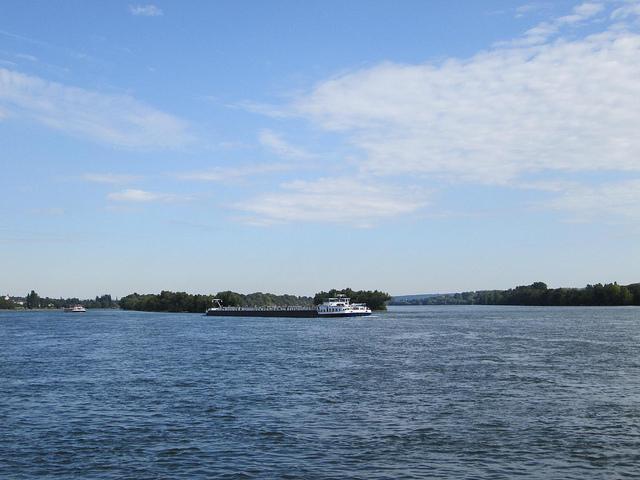How many people are wearing jeans in the image?
Give a very brief answer. 0. 